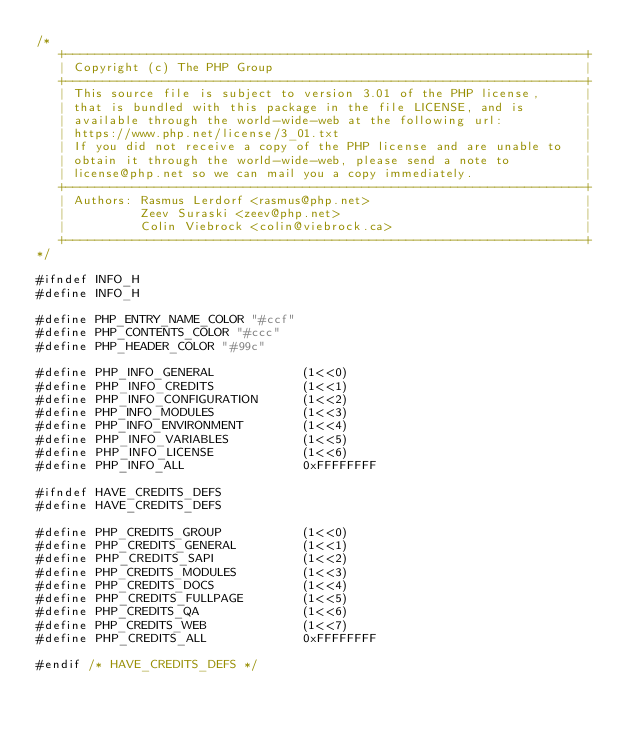Convert code to text. <code><loc_0><loc_0><loc_500><loc_500><_C_>/*
   +----------------------------------------------------------------------+
   | Copyright (c) The PHP Group                                          |
   +----------------------------------------------------------------------+
   | This source file is subject to version 3.01 of the PHP license,      |
   | that is bundled with this package in the file LICENSE, and is        |
   | available through the world-wide-web at the following url:           |
   | https://www.php.net/license/3_01.txt                                 |
   | If you did not receive a copy of the PHP license and are unable to   |
   | obtain it through the world-wide-web, please send a note to          |
   | license@php.net so we can mail you a copy immediately.               |
   +----------------------------------------------------------------------+
   | Authors: Rasmus Lerdorf <rasmus@php.net>                             |
   |          Zeev Suraski <zeev@php.net>                                 |
   |          Colin Viebrock <colin@viebrock.ca>                          |
   +----------------------------------------------------------------------+
*/

#ifndef INFO_H
#define INFO_H

#define PHP_ENTRY_NAME_COLOR "#ccf"
#define PHP_CONTENTS_COLOR "#ccc"
#define PHP_HEADER_COLOR "#99c"

#define PHP_INFO_GENERAL			(1<<0)
#define PHP_INFO_CREDITS			(1<<1)
#define PHP_INFO_CONFIGURATION		(1<<2)
#define PHP_INFO_MODULES			(1<<3)
#define PHP_INFO_ENVIRONMENT		(1<<4)
#define PHP_INFO_VARIABLES			(1<<5)
#define PHP_INFO_LICENSE			(1<<6)
#define PHP_INFO_ALL				0xFFFFFFFF

#ifndef HAVE_CREDITS_DEFS
#define HAVE_CREDITS_DEFS

#define PHP_CREDITS_GROUP			(1<<0)
#define PHP_CREDITS_GENERAL			(1<<1)
#define PHP_CREDITS_SAPI			(1<<2)
#define PHP_CREDITS_MODULES			(1<<3)
#define PHP_CREDITS_DOCS			(1<<4)
#define PHP_CREDITS_FULLPAGE		(1<<5)
#define PHP_CREDITS_QA				(1<<6)
#define PHP_CREDITS_WEB             (1<<7)
#define PHP_CREDITS_ALL				0xFFFFFFFF

#endif /* HAVE_CREDITS_DEFS */
</code> 